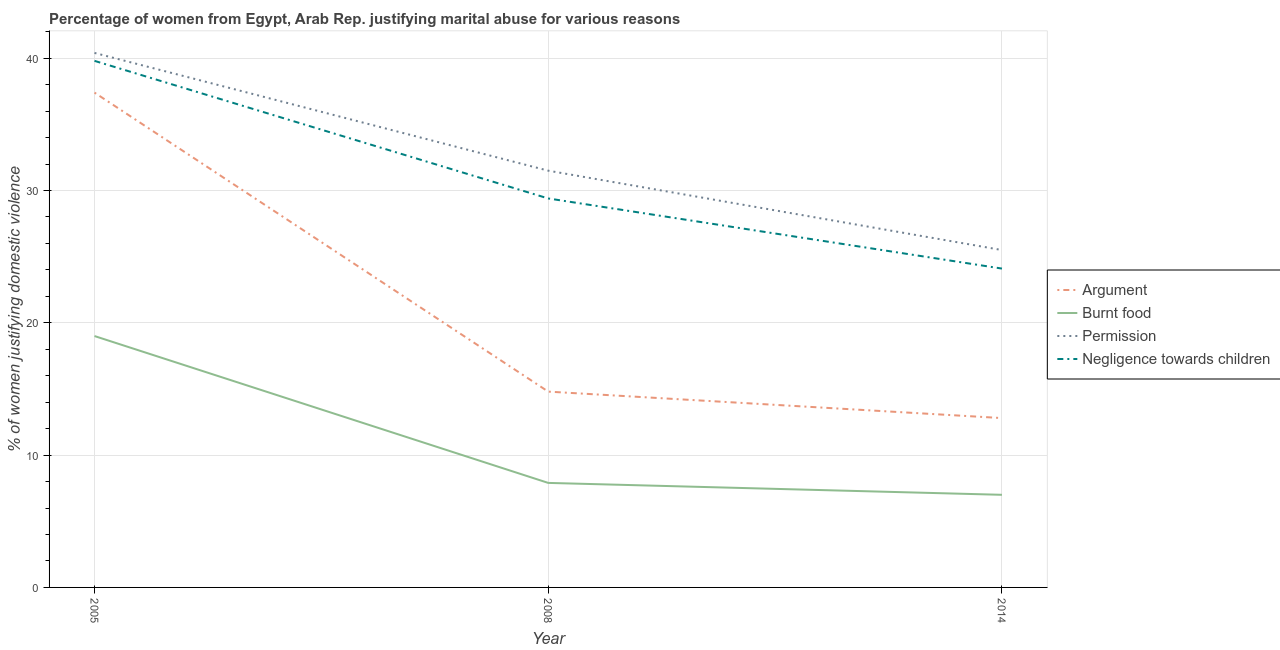Does the line corresponding to percentage of women justifying abuse in the case of an argument intersect with the line corresponding to percentage of women justifying abuse for going without permission?
Provide a short and direct response. No. What is the percentage of women justifying abuse for going without permission in 2005?
Provide a succinct answer. 40.4. Across all years, what is the maximum percentage of women justifying abuse in the case of an argument?
Make the answer very short. 37.4. Across all years, what is the minimum percentage of women justifying abuse for burning food?
Your answer should be very brief. 7. What is the total percentage of women justifying abuse for going without permission in the graph?
Provide a succinct answer. 97.4. What is the difference between the percentage of women justifying abuse for showing negligence towards children in 2005 and that in 2008?
Give a very brief answer. 10.4. What is the difference between the percentage of women justifying abuse in the case of an argument in 2014 and the percentage of women justifying abuse for going without permission in 2008?
Provide a succinct answer. -18.7. What is the average percentage of women justifying abuse for showing negligence towards children per year?
Provide a succinct answer. 31.1. In the year 2008, what is the difference between the percentage of women justifying abuse for going without permission and percentage of women justifying abuse for showing negligence towards children?
Offer a terse response. 2.1. In how many years, is the percentage of women justifying abuse for showing negligence towards children greater than 16 %?
Your answer should be compact. 3. What is the ratio of the percentage of women justifying abuse for burning food in 2005 to that in 2014?
Your answer should be very brief. 2.71. What is the difference between the highest and the second highest percentage of women justifying abuse for going without permission?
Your response must be concise. 8.9. What is the difference between the highest and the lowest percentage of women justifying abuse for showing negligence towards children?
Provide a succinct answer. 15.7. Is it the case that in every year, the sum of the percentage of women justifying abuse in the case of an argument and percentage of women justifying abuse for burning food is greater than the percentage of women justifying abuse for going without permission?
Your response must be concise. No. Does the percentage of women justifying abuse for burning food monotonically increase over the years?
Offer a terse response. No. How many lines are there?
Offer a terse response. 4. What is the difference between two consecutive major ticks on the Y-axis?
Your answer should be very brief. 10. Are the values on the major ticks of Y-axis written in scientific E-notation?
Provide a succinct answer. No. Does the graph contain grids?
Ensure brevity in your answer.  Yes. Where does the legend appear in the graph?
Offer a terse response. Center right. What is the title of the graph?
Provide a short and direct response. Percentage of women from Egypt, Arab Rep. justifying marital abuse for various reasons. What is the label or title of the X-axis?
Offer a very short reply. Year. What is the label or title of the Y-axis?
Your response must be concise. % of women justifying domestic violence. What is the % of women justifying domestic violence of Argument in 2005?
Make the answer very short. 37.4. What is the % of women justifying domestic violence in Permission in 2005?
Your response must be concise. 40.4. What is the % of women justifying domestic violence of Negligence towards children in 2005?
Give a very brief answer. 39.8. What is the % of women justifying domestic violence in Argument in 2008?
Your answer should be very brief. 14.8. What is the % of women justifying domestic violence of Burnt food in 2008?
Offer a terse response. 7.9. What is the % of women justifying domestic violence in Permission in 2008?
Offer a terse response. 31.5. What is the % of women justifying domestic violence of Negligence towards children in 2008?
Make the answer very short. 29.4. What is the % of women justifying domestic violence in Burnt food in 2014?
Make the answer very short. 7. What is the % of women justifying domestic violence of Permission in 2014?
Give a very brief answer. 25.5. What is the % of women justifying domestic violence in Negligence towards children in 2014?
Provide a succinct answer. 24.1. Across all years, what is the maximum % of women justifying domestic violence of Argument?
Give a very brief answer. 37.4. Across all years, what is the maximum % of women justifying domestic violence in Permission?
Your answer should be compact. 40.4. Across all years, what is the maximum % of women justifying domestic violence of Negligence towards children?
Provide a short and direct response. 39.8. Across all years, what is the minimum % of women justifying domestic violence of Burnt food?
Make the answer very short. 7. Across all years, what is the minimum % of women justifying domestic violence in Permission?
Your answer should be compact. 25.5. Across all years, what is the minimum % of women justifying domestic violence of Negligence towards children?
Ensure brevity in your answer.  24.1. What is the total % of women justifying domestic violence of Argument in the graph?
Make the answer very short. 65. What is the total % of women justifying domestic violence of Burnt food in the graph?
Provide a short and direct response. 33.9. What is the total % of women justifying domestic violence in Permission in the graph?
Provide a short and direct response. 97.4. What is the total % of women justifying domestic violence of Negligence towards children in the graph?
Ensure brevity in your answer.  93.3. What is the difference between the % of women justifying domestic violence in Argument in 2005 and that in 2008?
Your answer should be very brief. 22.6. What is the difference between the % of women justifying domestic violence of Negligence towards children in 2005 and that in 2008?
Provide a short and direct response. 10.4. What is the difference between the % of women justifying domestic violence of Argument in 2005 and that in 2014?
Keep it short and to the point. 24.6. What is the difference between the % of women justifying domestic violence of Burnt food in 2005 and that in 2014?
Offer a terse response. 12. What is the difference between the % of women justifying domestic violence of Permission in 2005 and that in 2014?
Your answer should be compact. 14.9. What is the difference between the % of women justifying domestic violence in Permission in 2008 and that in 2014?
Your response must be concise. 6. What is the difference between the % of women justifying domestic violence of Argument in 2005 and the % of women justifying domestic violence of Burnt food in 2008?
Give a very brief answer. 29.5. What is the difference between the % of women justifying domestic violence of Burnt food in 2005 and the % of women justifying domestic violence of Permission in 2008?
Give a very brief answer. -12.5. What is the difference between the % of women justifying domestic violence of Burnt food in 2005 and the % of women justifying domestic violence of Negligence towards children in 2008?
Your answer should be very brief. -10.4. What is the difference between the % of women justifying domestic violence of Permission in 2005 and the % of women justifying domestic violence of Negligence towards children in 2008?
Provide a succinct answer. 11. What is the difference between the % of women justifying domestic violence of Argument in 2005 and the % of women justifying domestic violence of Burnt food in 2014?
Offer a terse response. 30.4. What is the difference between the % of women justifying domestic violence in Argument in 2005 and the % of women justifying domestic violence in Permission in 2014?
Your answer should be compact. 11.9. What is the difference between the % of women justifying domestic violence in Burnt food in 2005 and the % of women justifying domestic violence in Negligence towards children in 2014?
Keep it short and to the point. -5.1. What is the difference between the % of women justifying domestic violence of Permission in 2005 and the % of women justifying domestic violence of Negligence towards children in 2014?
Offer a terse response. 16.3. What is the difference between the % of women justifying domestic violence in Argument in 2008 and the % of women justifying domestic violence in Burnt food in 2014?
Your answer should be compact. 7.8. What is the difference between the % of women justifying domestic violence in Burnt food in 2008 and the % of women justifying domestic violence in Permission in 2014?
Your answer should be very brief. -17.6. What is the difference between the % of women justifying domestic violence in Burnt food in 2008 and the % of women justifying domestic violence in Negligence towards children in 2014?
Your answer should be very brief. -16.2. What is the average % of women justifying domestic violence in Argument per year?
Offer a very short reply. 21.67. What is the average % of women justifying domestic violence in Burnt food per year?
Provide a short and direct response. 11.3. What is the average % of women justifying domestic violence of Permission per year?
Your answer should be compact. 32.47. What is the average % of women justifying domestic violence of Negligence towards children per year?
Ensure brevity in your answer.  31.1. In the year 2005, what is the difference between the % of women justifying domestic violence of Argument and % of women justifying domestic violence of Burnt food?
Provide a short and direct response. 18.4. In the year 2005, what is the difference between the % of women justifying domestic violence in Burnt food and % of women justifying domestic violence in Permission?
Your answer should be compact. -21.4. In the year 2005, what is the difference between the % of women justifying domestic violence in Burnt food and % of women justifying domestic violence in Negligence towards children?
Give a very brief answer. -20.8. In the year 2008, what is the difference between the % of women justifying domestic violence in Argument and % of women justifying domestic violence in Permission?
Your answer should be very brief. -16.7. In the year 2008, what is the difference between the % of women justifying domestic violence of Argument and % of women justifying domestic violence of Negligence towards children?
Keep it short and to the point. -14.6. In the year 2008, what is the difference between the % of women justifying domestic violence of Burnt food and % of women justifying domestic violence of Permission?
Offer a very short reply. -23.6. In the year 2008, what is the difference between the % of women justifying domestic violence in Burnt food and % of women justifying domestic violence in Negligence towards children?
Your answer should be compact. -21.5. In the year 2014, what is the difference between the % of women justifying domestic violence in Argument and % of women justifying domestic violence in Permission?
Offer a terse response. -12.7. In the year 2014, what is the difference between the % of women justifying domestic violence of Burnt food and % of women justifying domestic violence of Permission?
Ensure brevity in your answer.  -18.5. In the year 2014, what is the difference between the % of women justifying domestic violence in Burnt food and % of women justifying domestic violence in Negligence towards children?
Your answer should be compact. -17.1. What is the ratio of the % of women justifying domestic violence in Argument in 2005 to that in 2008?
Ensure brevity in your answer.  2.53. What is the ratio of the % of women justifying domestic violence in Burnt food in 2005 to that in 2008?
Provide a short and direct response. 2.41. What is the ratio of the % of women justifying domestic violence of Permission in 2005 to that in 2008?
Your response must be concise. 1.28. What is the ratio of the % of women justifying domestic violence in Negligence towards children in 2005 to that in 2008?
Your answer should be very brief. 1.35. What is the ratio of the % of women justifying domestic violence in Argument in 2005 to that in 2014?
Offer a terse response. 2.92. What is the ratio of the % of women justifying domestic violence of Burnt food in 2005 to that in 2014?
Your answer should be very brief. 2.71. What is the ratio of the % of women justifying domestic violence of Permission in 2005 to that in 2014?
Provide a short and direct response. 1.58. What is the ratio of the % of women justifying domestic violence in Negligence towards children in 2005 to that in 2014?
Keep it short and to the point. 1.65. What is the ratio of the % of women justifying domestic violence of Argument in 2008 to that in 2014?
Make the answer very short. 1.16. What is the ratio of the % of women justifying domestic violence of Burnt food in 2008 to that in 2014?
Provide a succinct answer. 1.13. What is the ratio of the % of women justifying domestic violence in Permission in 2008 to that in 2014?
Provide a short and direct response. 1.24. What is the ratio of the % of women justifying domestic violence in Negligence towards children in 2008 to that in 2014?
Your answer should be compact. 1.22. What is the difference between the highest and the second highest % of women justifying domestic violence in Argument?
Provide a short and direct response. 22.6. What is the difference between the highest and the second highest % of women justifying domestic violence in Burnt food?
Offer a very short reply. 11.1. What is the difference between the highest and the lowest % of women justifying domestic violence of Argument?
Ensure brevity in your answer.  24.6. What is the difference between the highest and the lowest % of women justifying domestic violence of Burnt food?
Offer a very short reply. 12. What is the difference between the highest and the lowest % of women justifying domestic violence of Permission?
Ensure brevity in your answer.  14.9. What is the difference between the highest and the lowest % of women justifying domestic violence of Negligence towards children?
Your response must be concise. 15.7. 